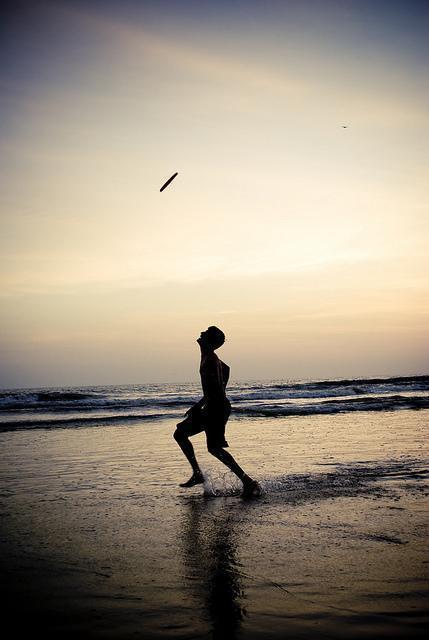How many giraffes are there?
Give a very brief answer. 0. 